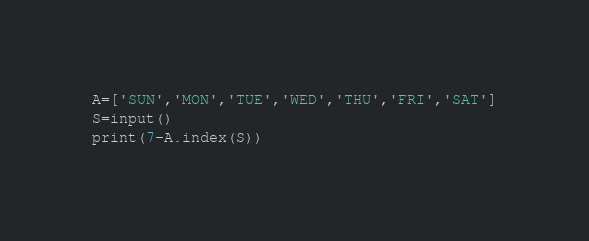Convert code to text. <code><loc_0><loc_0><loc_500><loc_500><_Python_>A=['SUN','MON','TUE','WED','THU','FRI','SAT']
S=input()
print(7-A.index(S))</code> 